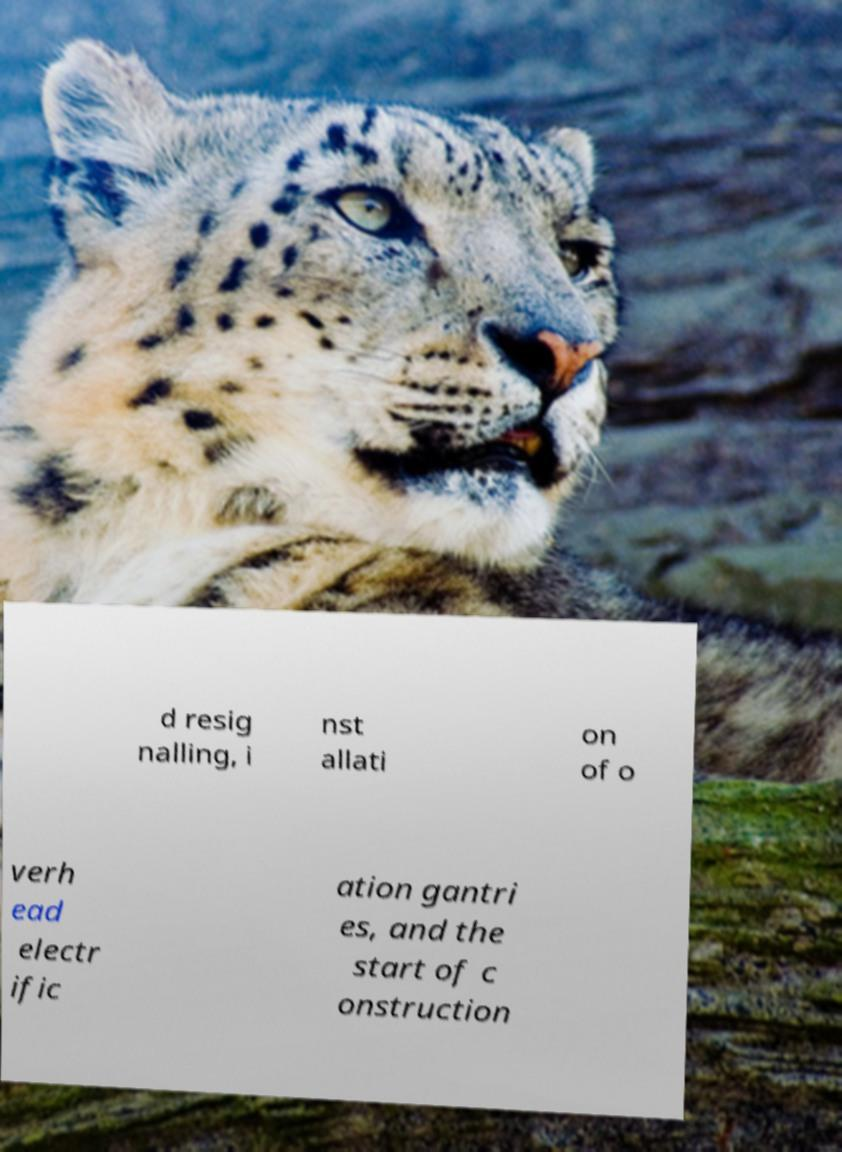For documentation purposes, I need the text within this image transcribed. Could you provide that? d resig nalling, i nst allati on of o verh ead electr ific ation gantri es, and the start of c onstruction 